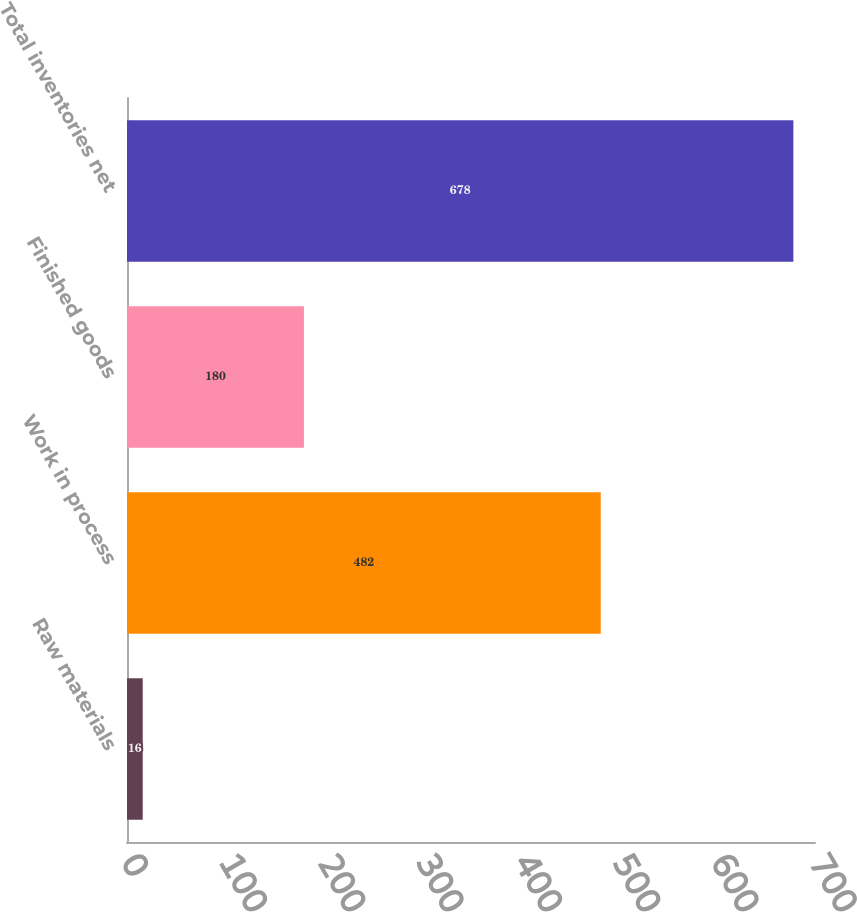Convert chart to OTSL. <chart><loc_0><loc_0><loc_500><loc_500><bar_chart><fcel>Raw materials<fcel>Work in process<fcel>Finished goods<fcel>Total inventories net<nl><fcel>16<fcel>482<fcel>180<fcel>678<nl></chart> 